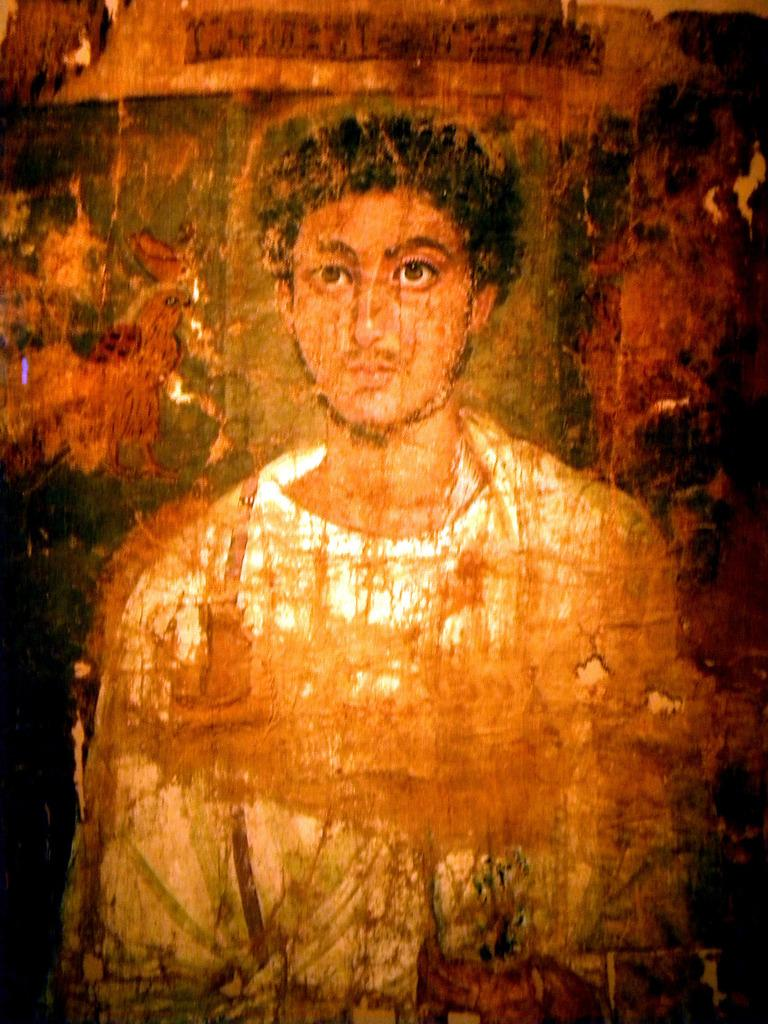What is the main subject of the image? There is a painting in the image. What does the painting depict? The painting depicts a person. What type of hook is being used by the person in the painting? There is no hook present in the painting; it depicts a person without any specific activity or object. What kind of toy is the person holding in the painting? There is no toy present in the painting; it only depicts a person. 